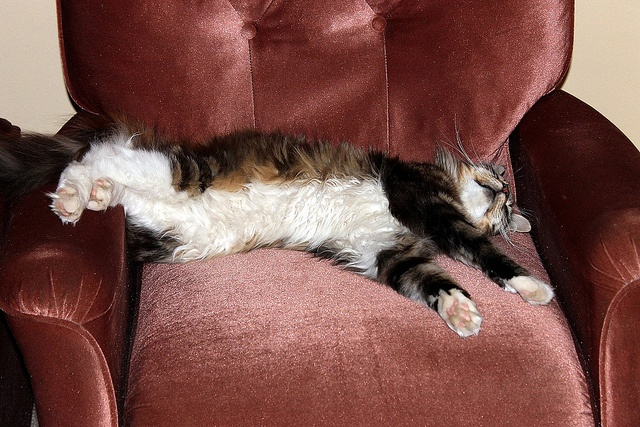Describe the objects in this image and their specific colors. I can see chair in maroon, black, tan, brown, and lightgray tones, couch in tan, maroon, brown, black, and lightpink tones, and cat in tan, lightgray, black, darkgray, and gray tones in this image. 